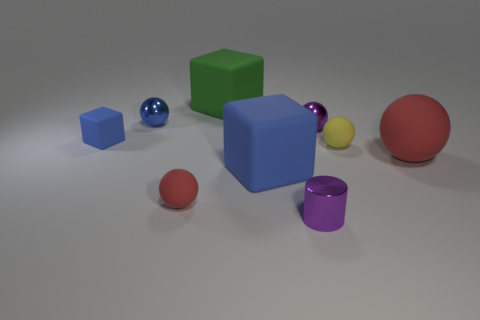Subtract all small matte spheres. How many spheres are left? 3 Subtract all green cylinders. How many red balls are left? 2 Add 1 cyan rubber spheres. How many objects exist? 10 Subtract all yellow spheres. How many spheres are left? 4 Subtract 4 spheres. How many spheres are left? 1 Subtract all blocks. How many objects are left? 6 Subtract all brown blocks. Subtract all red cylinders. How many blocks are left? 3 Subtract 0 red cylinders. How many objects are left? 9 Subtract all tiny purple things. Subtract all tiny cubes. How many objects are left? 6 Add 7 red things. How many red things are left? 9 